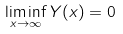Convert formula to latex. <formula><loc_0><loc_0><loc_500><loc_500>\liminf _ { x \to \infty } Y ( x ) = 0</formula> 